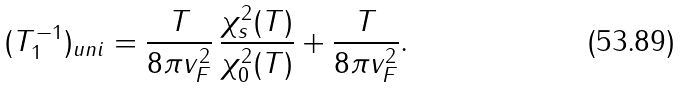<formula> <loc_0><loc_0><loc_500><loc_500>( T _ { 1 } ^ { - 1 } ) _ { u n i } = \frac { T } { 8 \pi v _ { F } ^ { 2 } } \, \frac { \chi _ { s } ^ { 2 } ( T ) } { \chi _ { 0 } ^ { 2 } ( T ) } + \frac { T } { 8 \pi v _ { F } ^ { 2 } } .</formula> 